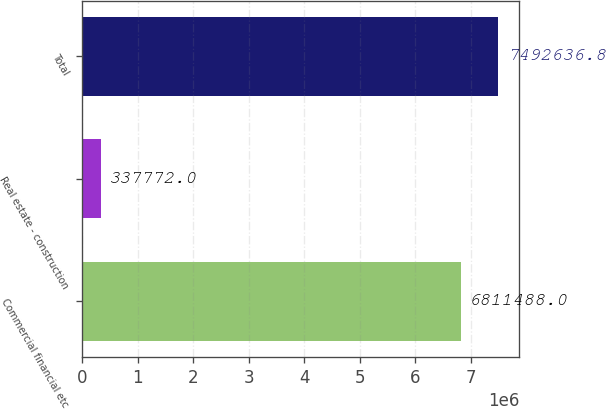Convert chart to OTSL. <chart><loc_0><loc_0><loc_500><loc_500><bar_chart><fcel>Commercial financial etc<fcel>Real estate - construction<fcel>Total<nl><fcel>6.81149e+06<fcel>337772<fcel>7.49264e+06<nl></chart> 